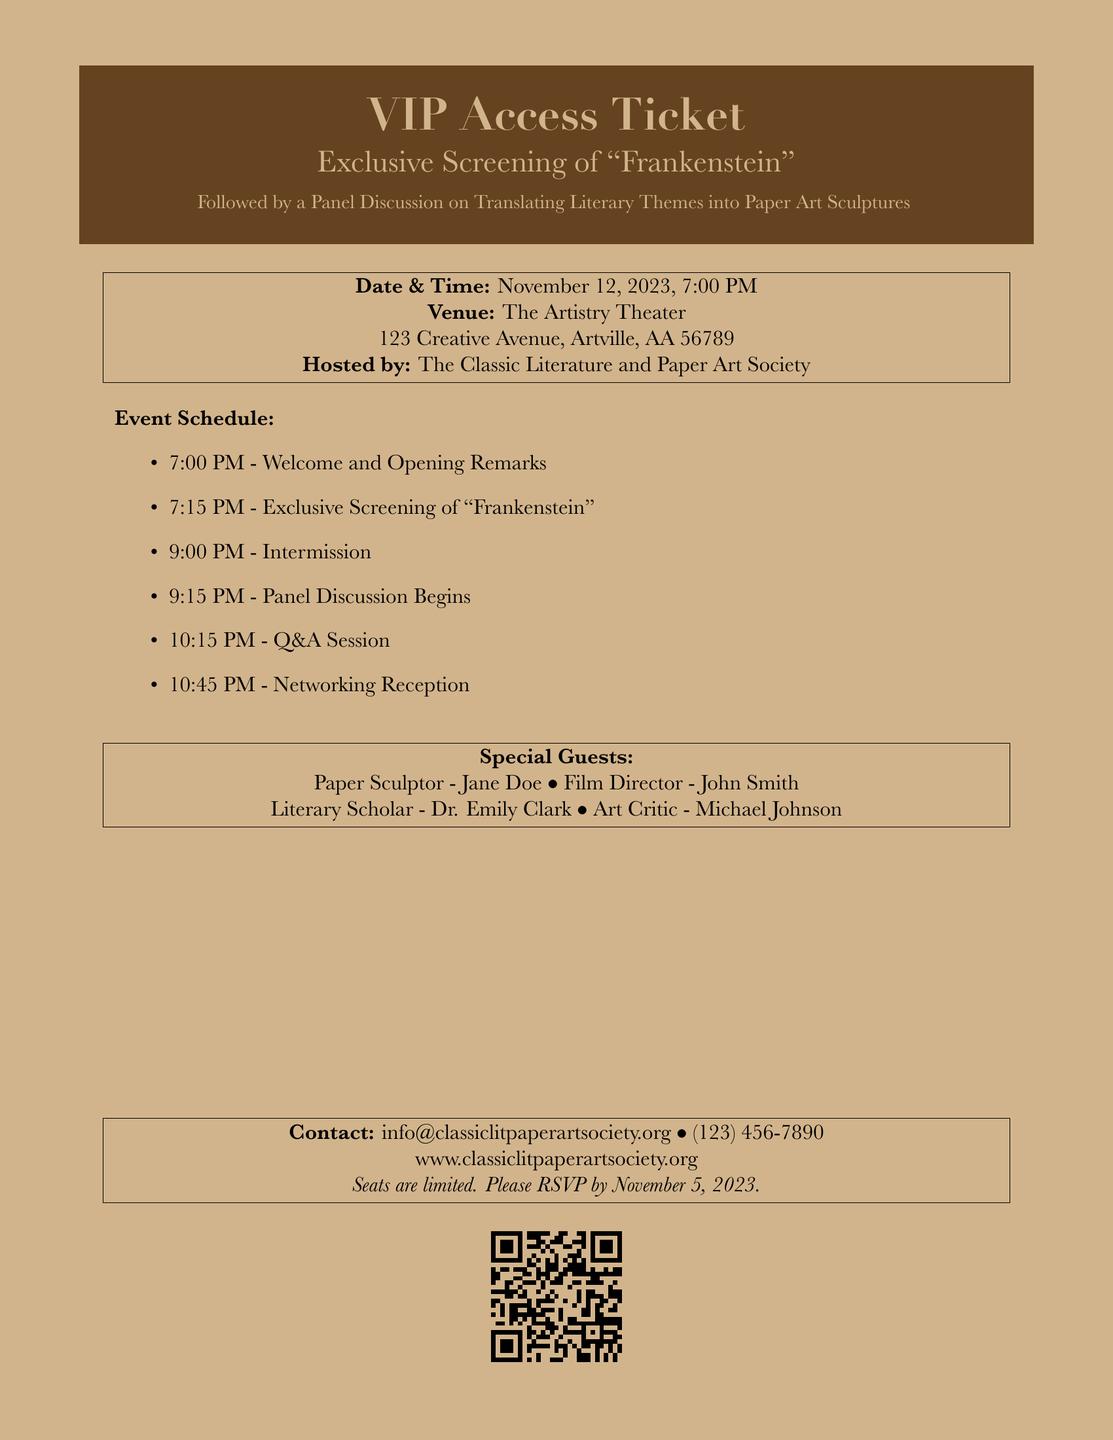What is the date of the event? The date of the event is explicitly stated in the document as November 12, 2023.
Answer: November 12, 2023 What time does the panel discussion begin? The panel discussion time is listed under the event schedule as starting at 9:15 PM.
Answer: 9:15 PM Who is the paper sculptor guest? The document names Jane Doe as the paper sculptor special guest.
Answer: Jane Doe Where is the venue located? The venue address is clearly provided in the document as The Artistry Theater, 123 Creative Avenue, Artville, AA 56789.
Answer: The Artistry Theater, 123 Creative Avenue, Artville, AA 56789 What is the RSVPing deadline for the event? The document highlights that the RSVP deadline is November 5, 2023.
Answer: November 5, 2023 How long is the intermission expected to last? The intermission is mentioned in the event schedule and is positioned between the exclusive screening and the panel discussion. It lasts for approximately 15 minutes.
Answer: 15 minutes Who are the special guests? Special guests are clearly listed in the document as Jane Doe, John Smith, Dr. Emily Clark, and Michael Johnson.
Answer: Jane Doe, John Smith, Dr. Emily Clark, Michael Johnson What is the contact phone number? The document provides the contact number clearly, which is (123) 456-7890.
Answer: (123) 456-7890 Which organization is hosting the event? The hosting organization is specified at the beginning of the venue details as The Classic Literature and Paper Art Society.
Answer: The Classic Literature and Paper Art Society 